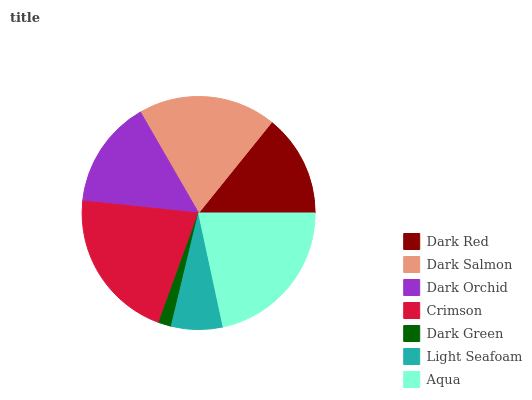Is Dark Green the minimum?
Answer yes or no. Yes. Is Aqua the maximum?
Answer yes or no. Yes. Is Dark Salmon the minimum?
Answer yes or no. No. Is Dark Salmon the maximum?
Answer yes or no. No. Is Dark Salmon greater than Dark Red?
Answer yes or no. Yes. Is Dark Red less than Dark Salmon?
Answer yes or no. Yes. Is Dark Red greater than Dark Salmon?
Answer yes or no. No. Is Dark Salmon less than Dark Red?
Answer yes or no. No. Is Dark Orchid the high median?
Answer yes or no. Yes. Is Dark Orchid the low median?
Answer yes or no. Yes. Is Dark Green the high median?
Answer yes or no. No. Is Dark Salmon the low median?
Answer yes or no. No. 